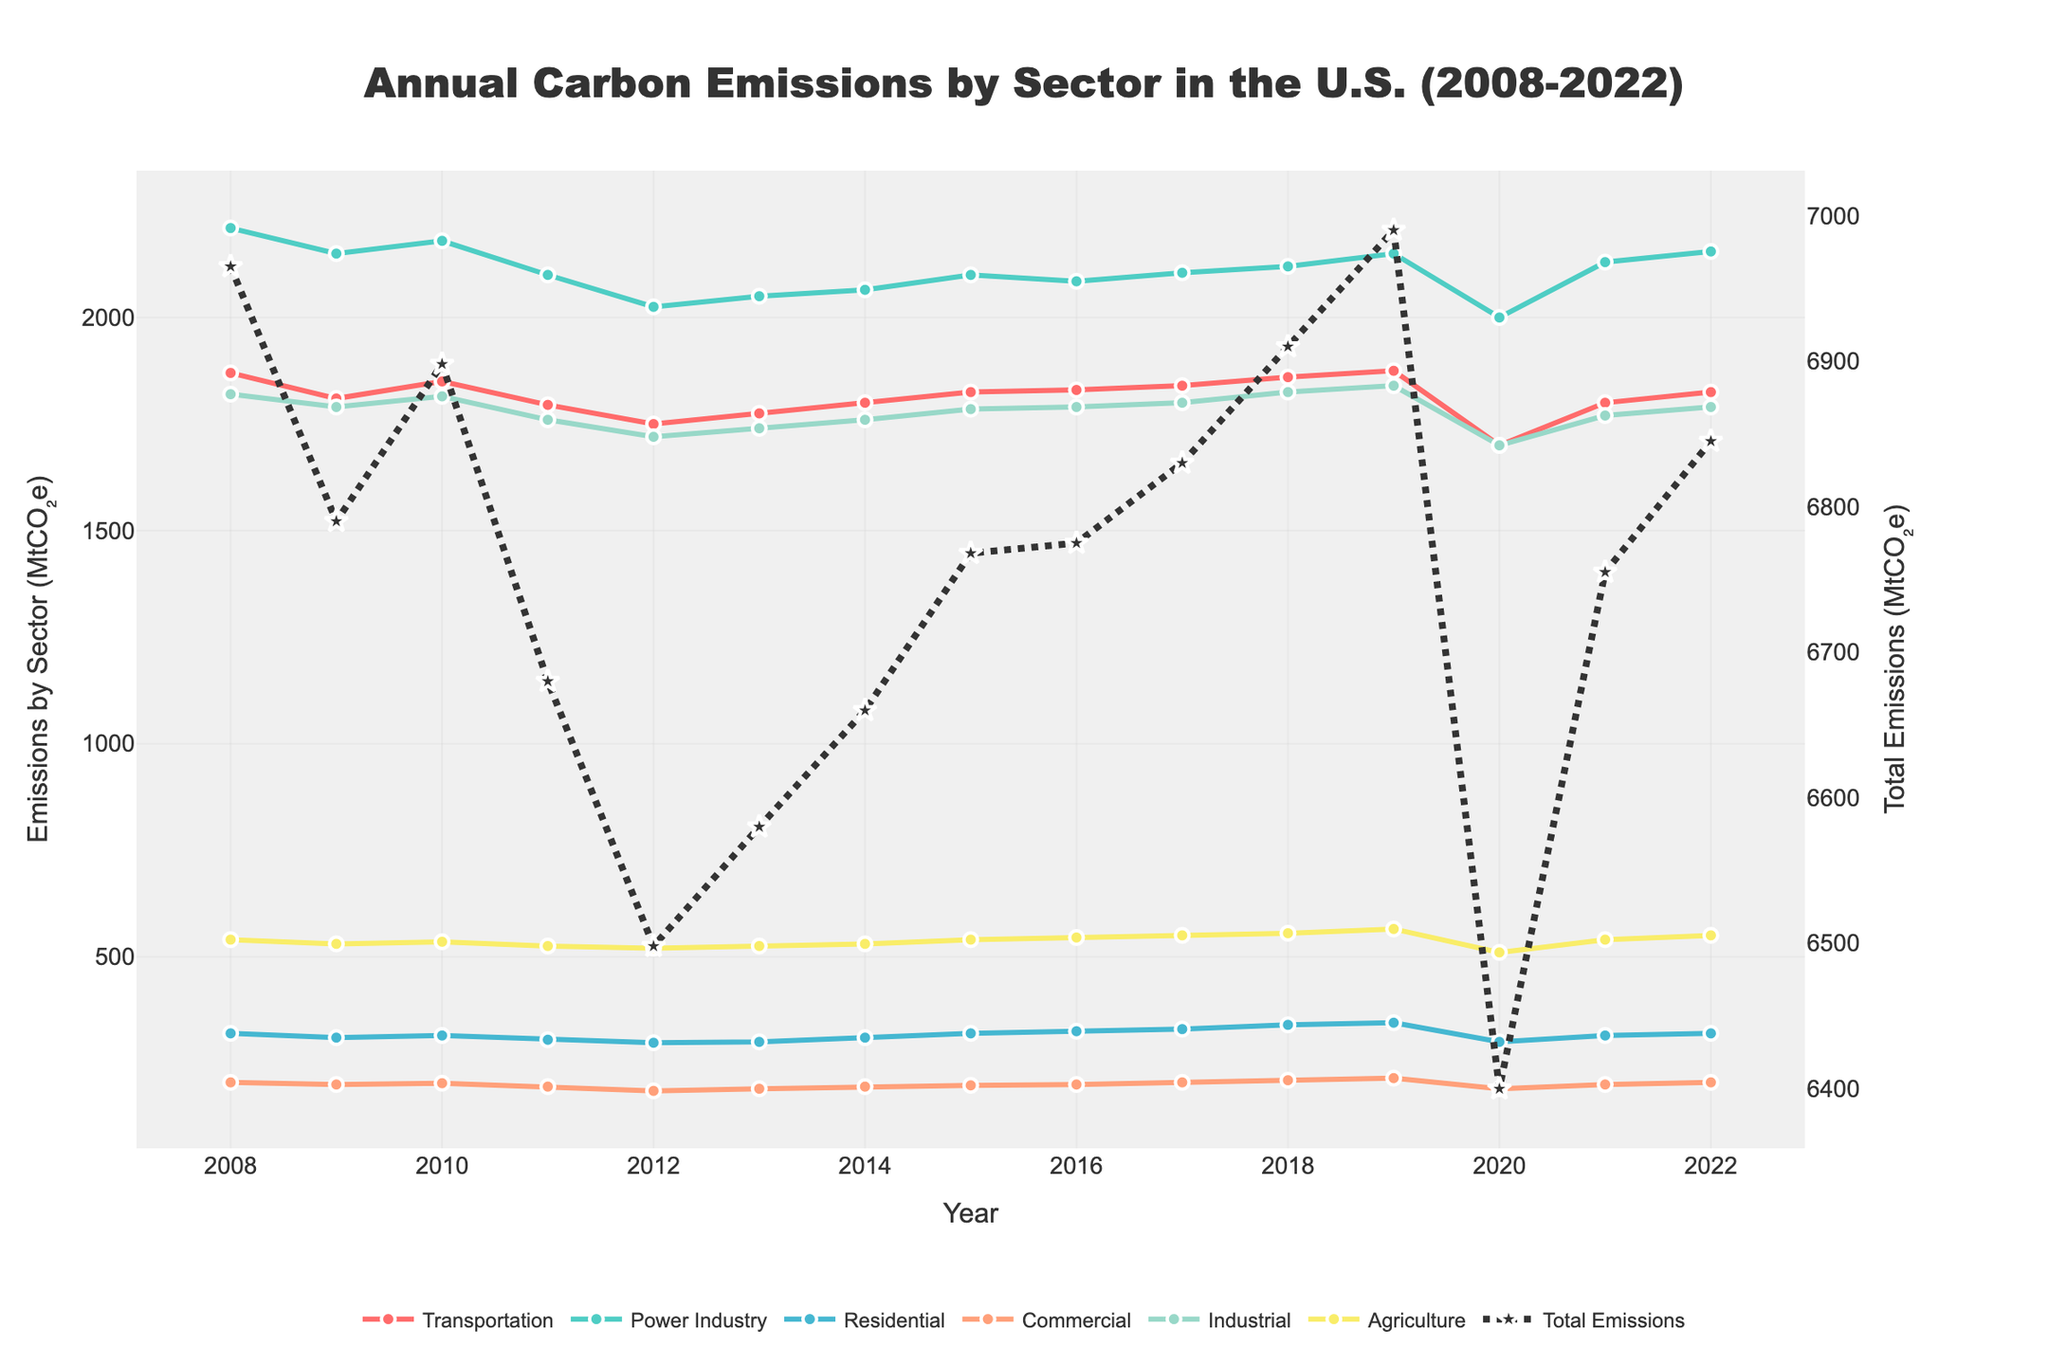What is the title of the figure? The title is typically located at the top of the figure and it gives an overview or main idea about what the figure represents. By looking at the figure, we can read the title directly.
Answer: Annual Carbon Emissions by Sector in the U.S. (2008-2022) How many sectors of carbon emissions are plotted in the figure? The number of sectors can be counted by checking the legend of the plot which lists all sectors individually.
Answer: Six Which sector had the highest emissions in 2008? To find this, look at the 2008 point on the x-axis and see which sector's line is highest vertically above this year.
Answer: Power Industry What was the total carbon emission in the U.S. in the year 2018? Look at the line representing total emissions and find its value at the year 2018 on the x-axis.
Answer: Approximately 7,910 MtCO₂e Which sector showed a decrease in emissions from 2019 to 2020? Observe the trend from 2019 to 2020 for each sector and identify the lines that slope downward between these two years.
Answer: Transportation, Power Industry, Residential, Commercial, Industrial, Agriculture How did the residential sector's emissions change from 2008 to 2022? Follow the residential sector's line from 2008 to 2022 to see if it generally trends upwards, downwards, or remains stable.
Answer: Mostly stable with slight fluctuations What is the general trend of total carbon emissions across the 15 years? Look at the total emissions line and see if it generally increases, decreases, or remains stable over the time period.
Answer: Generally decreasing In which year did the transportation sector reach its lowest emission level? Identify the lowest point of the transportation sector line and match it to the corresponding year on the x-axis.
Answer: 2020 Compare the carbon emissions from the industrial sector and commercial sector in 2021. Which one is higher? Locate the data points for the industrial and commercial sectors in 2021 and compare their values.
Answer: Industrial sector What was the percentage change in agriculture sector emissions from 2008 to 2022? Calculate the percentage change using the formula: ((Emissions in 2022 - Emissions in 2008) / Emissions in 2008) * 100%.
Answer: ((550 - 540) / 540) * 100% = 1.85% 